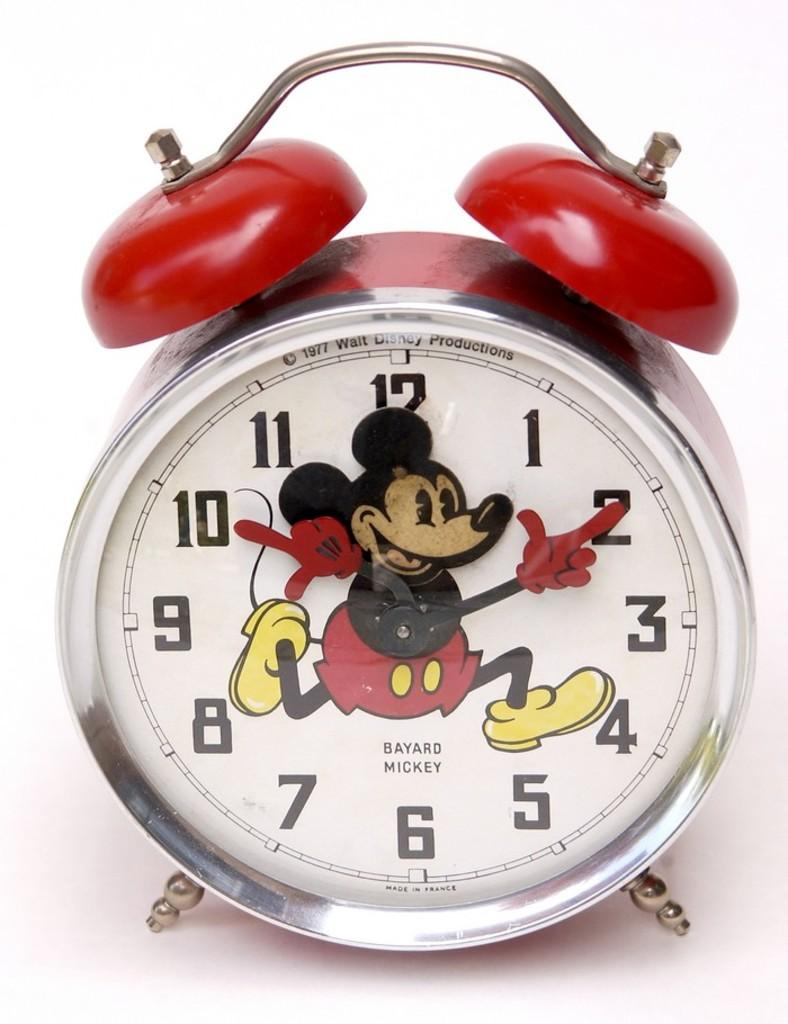<image>
Present a compact description of the photo's key features. A mickey mouse clock displaying a copyright from 1977 